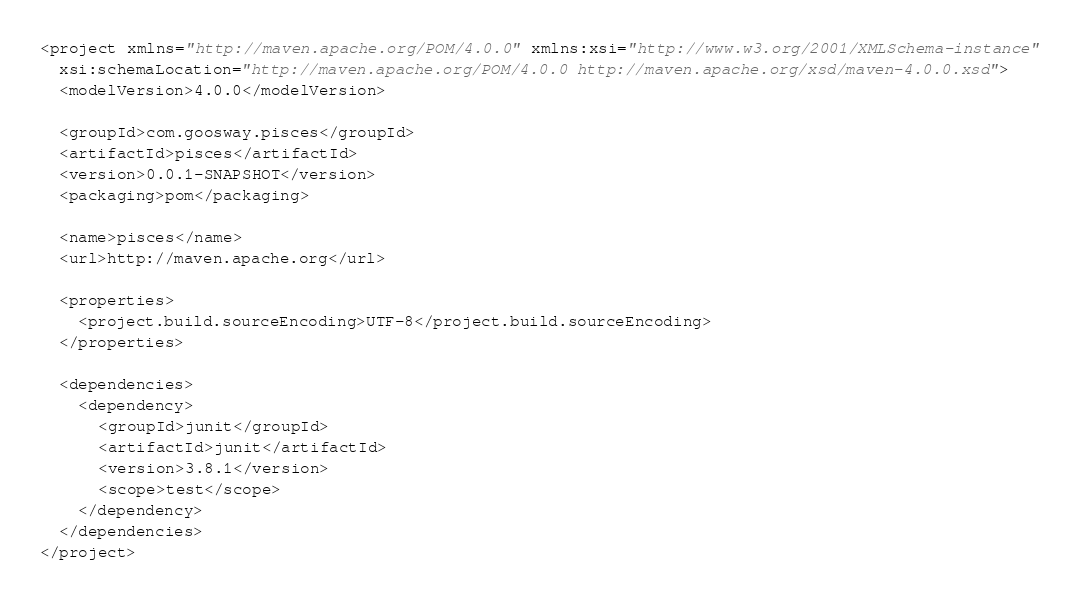Convert code to text. <code><loc_0><loc_0><loc_500><loc_500><_XML_><project xmlns="http://maven.apache.org/POM/4.0.0" xmlns:xsi="http://www.w3.org/2001/XMLSchema-instance"
  xsi:schemaLocation="http://maven.apache.org/POM/4.0.0 http://maven.apache.org/xsd/maven-4.0.0.xsd">
  <modelVersion>4.0.0</modelVersion>

  <groupId>com.goosway.pisces</groupId>
  <artifactId>pisces</artifactId>
  <version>0.0.1-SNAPSHOT</version>
  <packaging>pom</packaging>

  <name>pisces</name>
  <url>http://maven.apache.org</url>

  <properties>
    <project.build.sourceEncoding>UTF-8</project.build.sourceEncoding>
  </properties>

  <dependencies>
    <dependency>
      <groupId>junit</groupId>
      <artifactId>junit</artifactId>
      <version>3.8.1</version>
      <scope>test</scope>
    </dependency>
  </dependencies>
</project>
</code> 